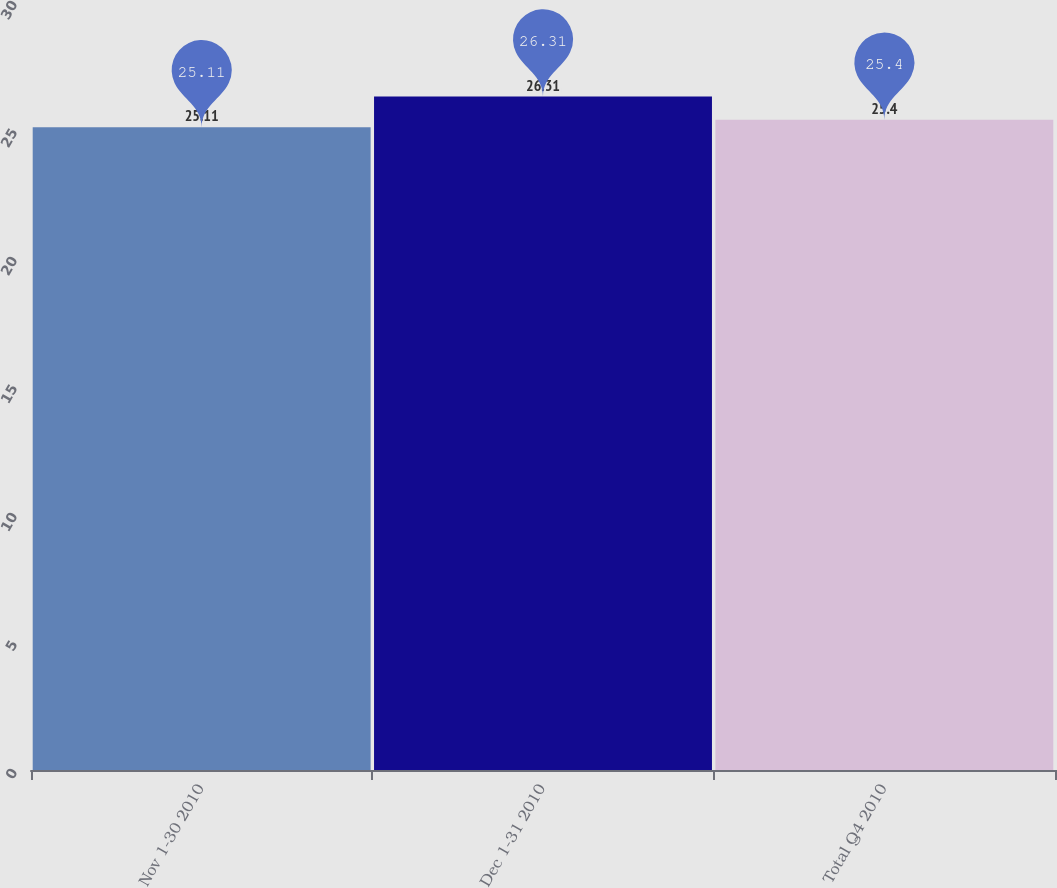Convert chart to OTSL. <chart><loc_0><loc_0><loc_500><loc_500><bar_chart><fcel>Nov 1-30 2010<fcel>Dec 1-31 2010<fcel>Total Q4 2010<nl><fcel>25.11<fcel>26.31<fcel>25.4<nl></chart> 